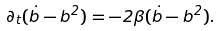Convert formula to latex. <formula><loc_0><loc_0><loc_500><loc_500>\partial _ { t } { ( \dot { b } - b ^ { 2 } ) } = - 2 \beta ( \dot { b } - b ^ { 2 } ) .</formula> 